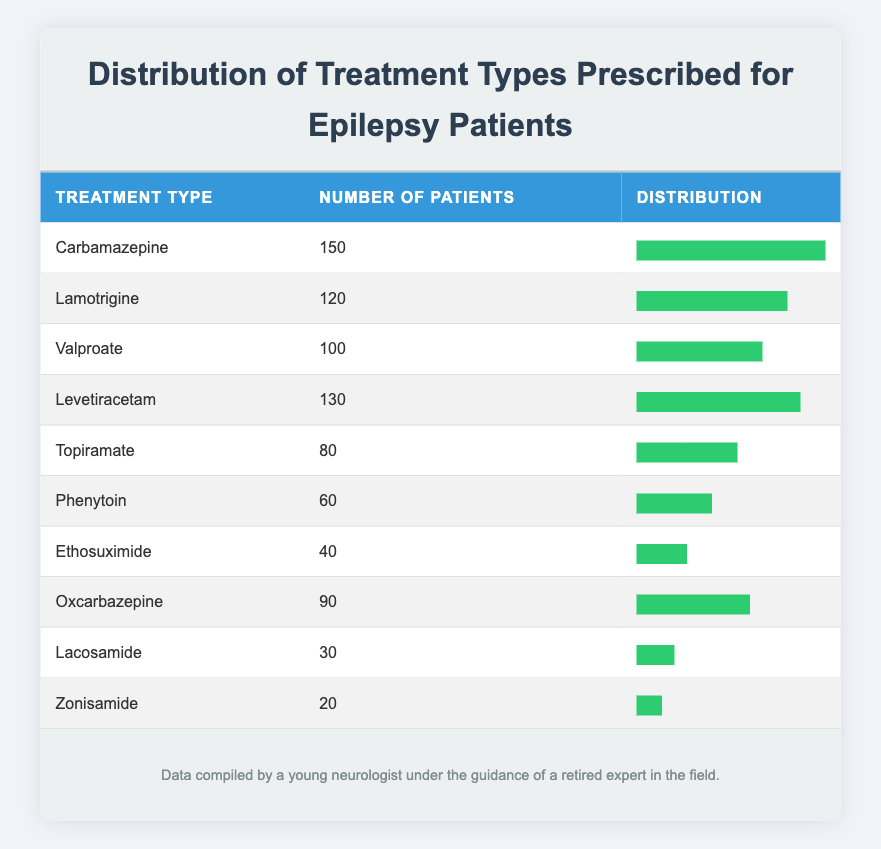What is the treatment type prescribed for the highest number of patients? Looking at the table, "Carbamazepine" has the highest number of patients prescribed at 150.
Answer: Carbamazepine How many patients are prescribed Valproate? Referring to the table, Valproate is prescribed to 100 patients.
Answer: 100 What is the total number of patients across all treatment types? To find the total, we sum the number of patients: 150 + 120 + 100 + 130 + 80 + 60 + 40 + 90 + 30 + 20 = 1,020.
Answer: 1,020 How does the number of patients treated with Lamotrigine compare to those treated with Topiramate? Lamotrigine has 120 patients while Topiramate has 80 patients. This shows that Lamotrigine is prescribed to 40 more patients than Topiramate.
Answer: Lamotrigine has more patients by 40 Is the number of patients prescribed Lacosamide greater than the number of patients prescribed Levetiracetam? Lacosamide has 30 patients while Levetiracetam has 130 patients. Therefore, it is false that Lacosamide has more patients.
Answer: No What percentage of patients are treated with Phenytoin compared to the total number of patients? Phenytoin has 60 patients, and the total is 1,020. The percentage calculation is (60 / 1,020) x 100 = 5.88%.
Answer: 5.88% What is the median number of patients across the treatment types? To find the median, we first list the number of patients in ascending order: 20, 30, 40, 60, 80, 90, 100, 120, 130, 150. There are 10 values, so the median is the average of the 5th and 6th values: (80 + 90) / 2 = 85.
Answer: 85 Is the total number of patients treated with the top three prescribed treatments more than those treated with the bottom three? The total for the top three (Carbamazepine, Lamotrigine, Levetiracetam) is 150 + 120 + 130 = 400. The total for the bottom three (Lacosamide, Zonisamide, Ethosuximide) is 30 + 20 + 40 = 90. Therefore, 400 > 90 is true.
Answer: Yes How many more patients are treated with Oxcarbazepine compared to Ethosuximide? Oxcarbazepine has 90 patients and Ethosuximide has 40 patients, which provides a difference of 90 - 40 = 50 patients.
Answer: 50 patients 